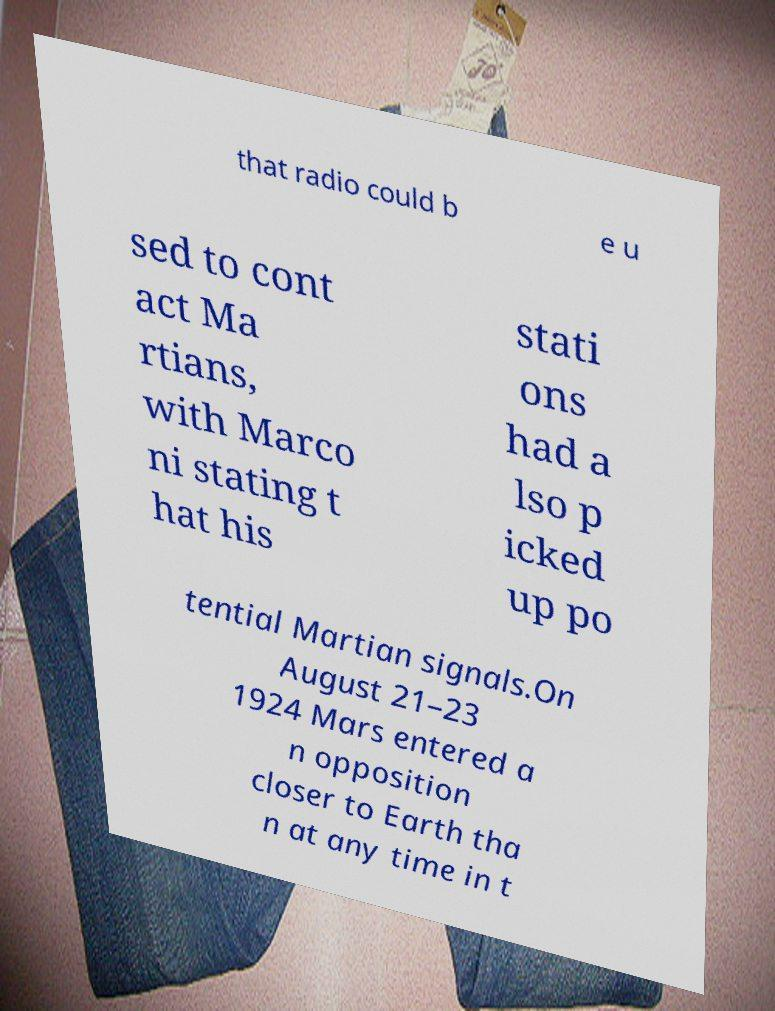Can you accurately transcribe the text from the provided image for me? that radio could b e u sed to cont act Ma rtians, with Marco ni stating t hat his stati ons had a lso p icked up po tential Martian signals.On August 21–23 1924 Mars entered a n opposition closer to Earth tha n at any time in t 